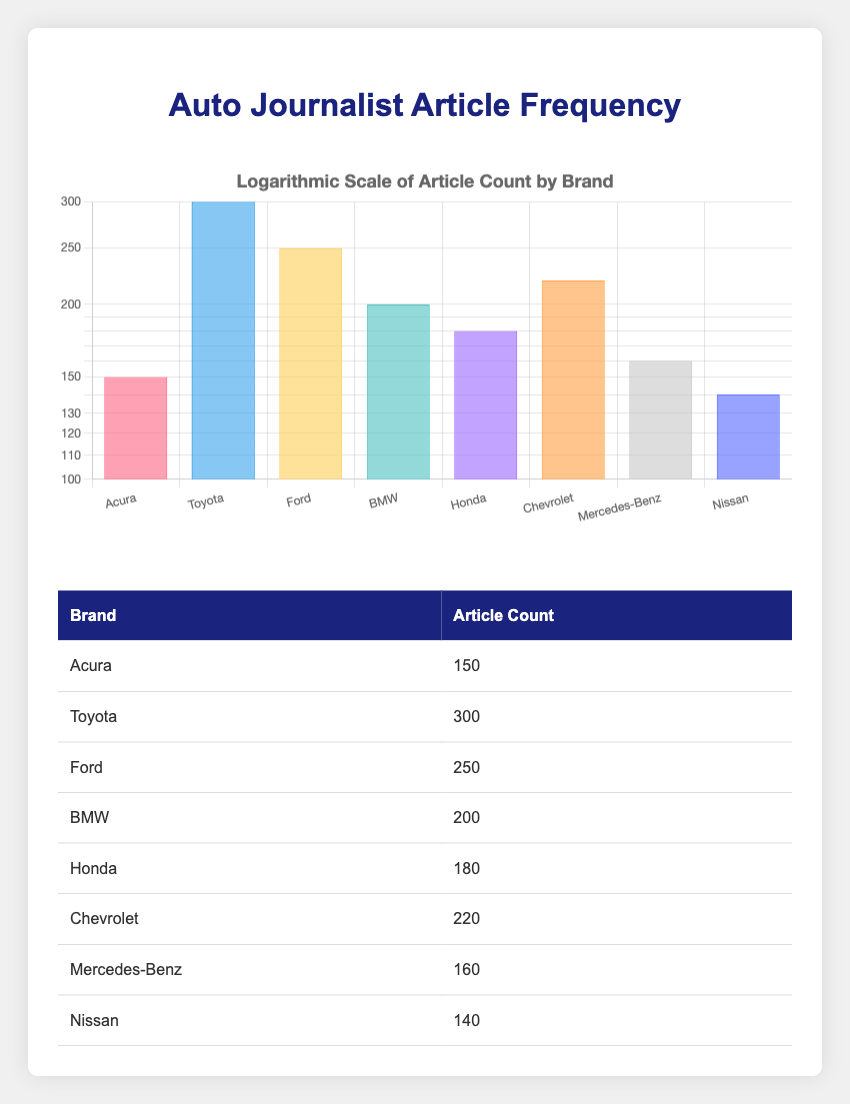What is the article count for Acura? The table lists the article count for Acura directly in the corresponding row, which is 150.
Answer: 150 Which brand has the highest article count? By looking at the article counts in the table, we can see that Toyota has the highest count at 300.
Answer: Toyota How many more articles did Ford have compared to Acura? The article count for Ford is 250 and for Acura, it is 150. The difference can be calculated as 250 - 150 = 100.
Answer: 100 Are there more articles about Chevrolet than Honda? Chevrolet has an article count of 220, while Honda has 180. Since 220 is greater than 180, we can say yes.
Answer: Yes What is the total number of articles for Nissan and Mercedes-Benz? The article counts for Nissan and Mercedes-Benz are 140 and 160, respectively. Adding these counts gives us 140 + 160 = 300.
Answer: 300 What is the average article count for BMW and Chevrolet? The article counts for BMW and Chevrolet are 200 and 220, respectively. Adding these gives us 200 + 220 = 420, then dividing by 2 to find the average gives us 420 / 2 = 210.
Answer: 210 Is the article count for Acura less than the average of all brands' article counts? First, we need to find the total article count: 150 (Acura) + 300 (Toyota) + 250 (Ford) + 200 (BMW) + 180 (Honda) + 220 (Chevrolet) + 160 (Mercedes-Benz) + 140 (Nissan) = 1600. Then, we divide this by the number of brands (8) to get the average: 1600 / 8 = 200. Since 150 (Acura's count) is less than 200, the answer is yes.
Answer: Yes What is the difference between the article counts of BMW and Toyota? BMW has 200 articles, and Toyota has 300 articles. Subtracting these gives us 300 - 200 = 100.
Answer: 100 Which brands have an article count greater than Acura? The brands with a count greater than Acura are Toyota (300), Ford (250), BMW (200), Honda (180), and Chevrolet (220). There are 5 brands in total.
Answer: 5 